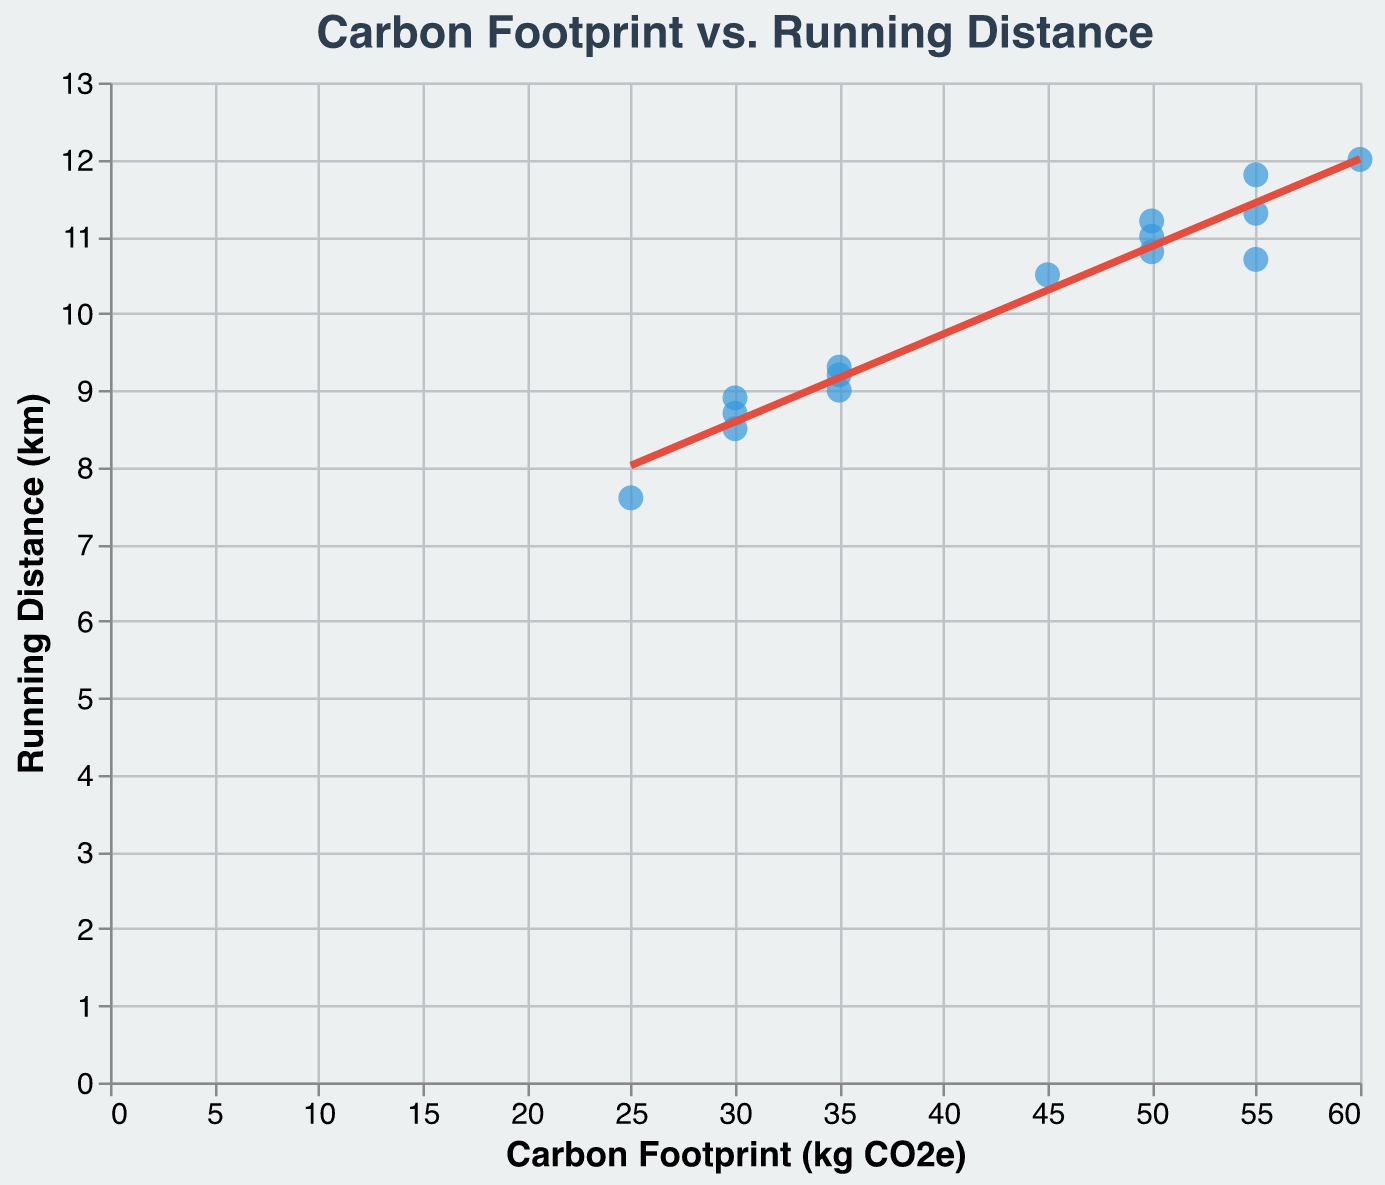What is the title of the scatter plot? The title of the scatter plot is often the most prominent text at the top of the chart.
Answer: Carbon Footprint vs. Running Distance How many data points are plotted on the scatter plot? Each data point corresponds to a player. Counting each point provides the total number of data points.
Answer: 15 Which player has the highest carbon footprint? By locating the highest value on the x-axis (Carbon Footprint), we can identify the corresponding player from the tooltip or point.
Answer: Kylian Mbappe What is the running distance for Lionel Messi? Hovering over the data point or referring to the tooltip will reveal the running distance.
Answer: 11.2 km Which players have the same carbon footprint? Identifying players with overlapping points on the x-axis reveals those with the same carbon footprint.
Answer: Lionel Messi, Kevin De Bruyne, Harry Kane What is the general trend between carbon footprint and running distance? Observing the trend line and its direction gives an indication of the overall relationship.
Answer: Positive trend Compare the carbon footprints of Megan Rapinoe and Cristiano Ronaldo. Who has the higher carbon footprint? By finding both players' points and comparing their positions on the x-axis, the player farther to the right has the higher carbon footprint.
Answer: Cristiano Ronaldo Which player has the longest running distance and what is their carbon footprint? Locate the point with the highest y-value and refer to the tooltip for the corresponding x-value.
Answer: Kylian Mbappe (12.0 km, 60 kg CO2e) Is there any player with a carbon footprint below 30 kg CO2e? By observing the x-axis for values below 30 and finding any corresponding points, we can identify players, if any.
Answer: Yes, Marta Vieira da Silva What is the difference in running distance between the player with the highest and lowest carbon footprints? First, identify the players with the highest (Kylian Mbappe) and lowest (Marta Vieira da Silva) carbon footprints. Then, subtract their running distances.
Answer: 12.0 km - 7.6 km = 4.4 km 